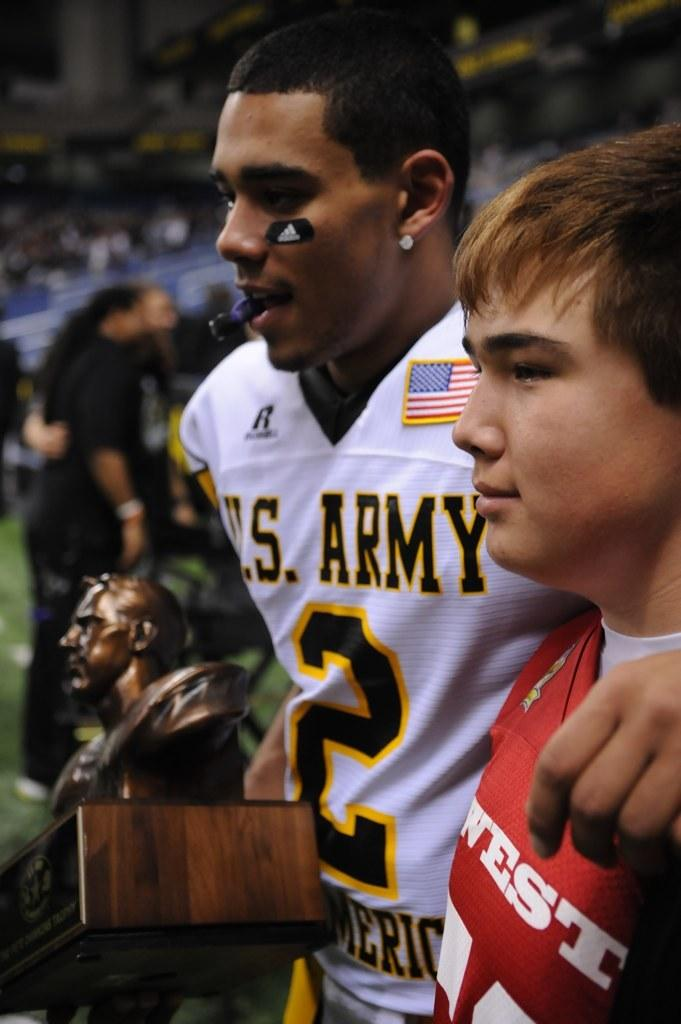Provide a one-sentence caption for the provided image. A man in a us army jersey holds a trophy while his arms around a young man wearing a red jersey. 